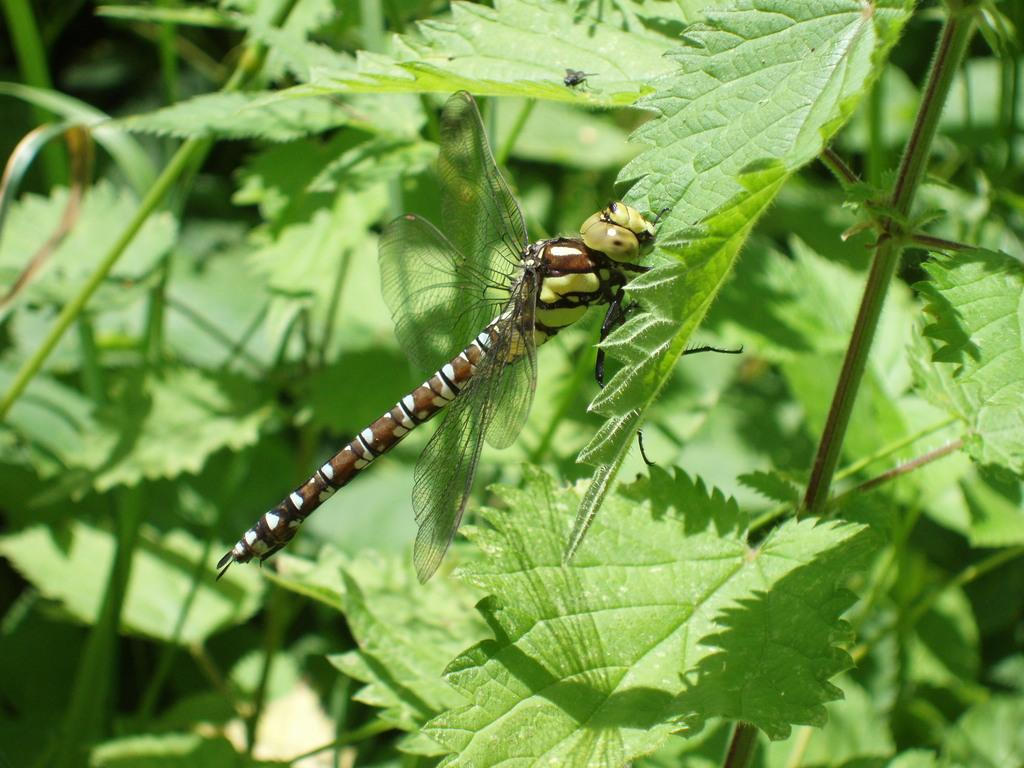What type of creatures can be seen in the image? There are insects in the image. Where are the insects located? The insects are on plants. How many kittens are comfortably sitting on the drum in the image? There are no kittens or drums present in the image. 